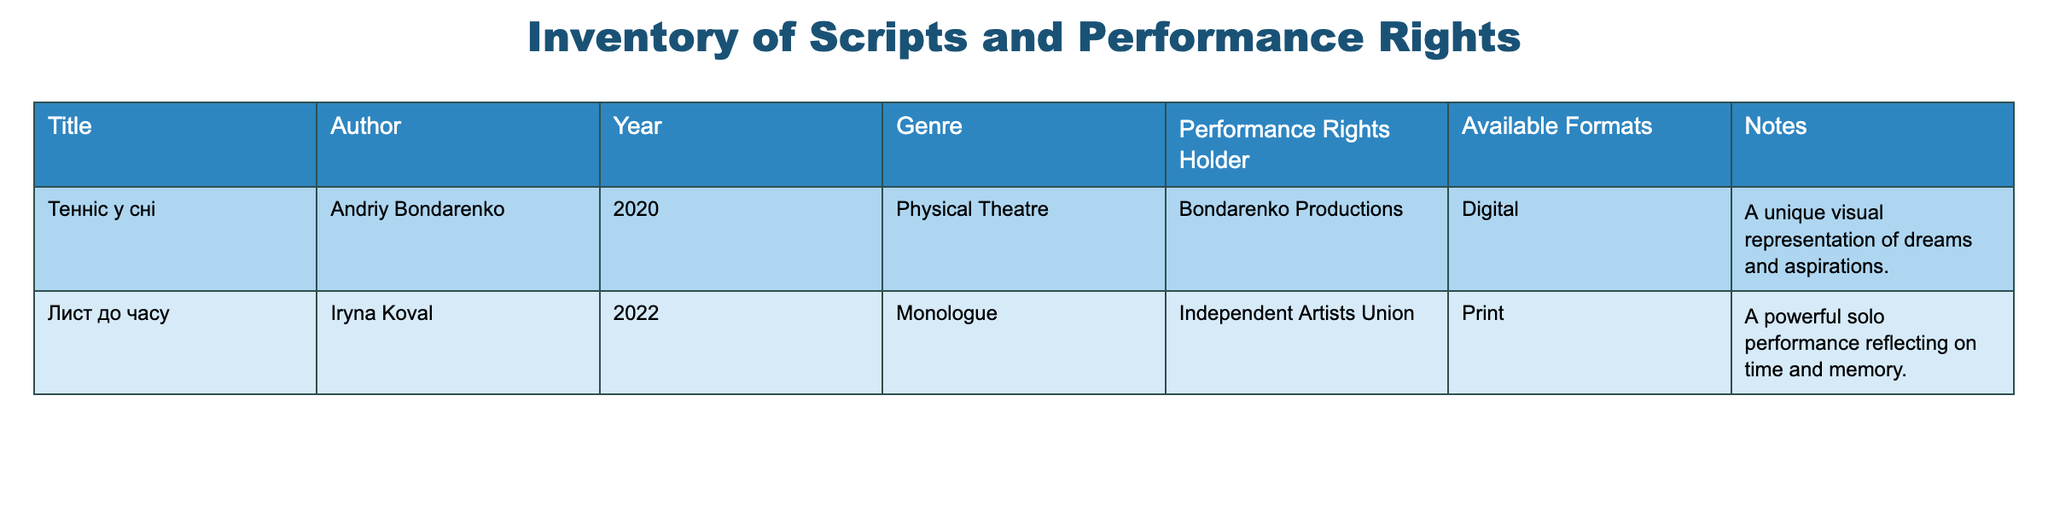What are the titles of the plays listed in the inventory? The titles of the plays can be found in the first column of the table. They are "Тенніс у сні" and "Лист до часу".
Answer: "Тенніс у сні", "Лист до часу" Who is the author of "Лист до часу"? The author information is presented in the second column of the table. For "Лист до часу," the author is Iryna Koval.
Answer: Iryna Koval Is the performance rights holder for "Тенніс у сні" the same as for "Лист до часу"? To answer this, I compare the performance rights holders listed in the fifth column. "Тенніс у сні" is held by Bondarenko Productions, while "Лист до часу" is held by the Independent Artists Union. Since these are different, the answer is no.
Answer: No What genre does the play "Тенніс у сні" belong to? The genre is found in the fourth column of the table. For "Тенніс у сні," it is classified as "Physical Theatre."
Answer: Physical Theatre What is the year of publication for the newest play? The year of publication is in the third column. I compare the years of both plays: 2020 for "Тенніс у сні" and 2022 for "Лист до часу." Since 2022 is more recent, the answer is 2022 for "Лист до часу."
Answer: 2022 How many different available formats are listed in the inventory? The available formats can be seen in the sixth column. There are two unique formats: "Digital" for "Тенніс у сні" and "Print" for "Лист до часу." Thus, there are two different formats in total.
Answer: 2 Does "Лист до часу" have any notes listed? The notes for "Лист до часу" can be found in the notes column. It states that it reflects on time and memory, which means there is a note associated. Hence, the answer is yes.
Answer: Yes Which play has a unique visual representation according to the notes? I need to look at the notes column and find the play mentioned. The note for "Тенніс у сні" states it has a unique visual representation of dreams and aspirations. Therefore, the answer is "Тенніс у сні."
Answer: Тенніс у сні If you combine the genres of both plays, how many distinct genres are represented? The genres listed are "Physical Theatre" for "Тенніс у сні" and "Monologue" for "Лист до часу." Since both are different, there are two distinct genres.
Answer: 2 